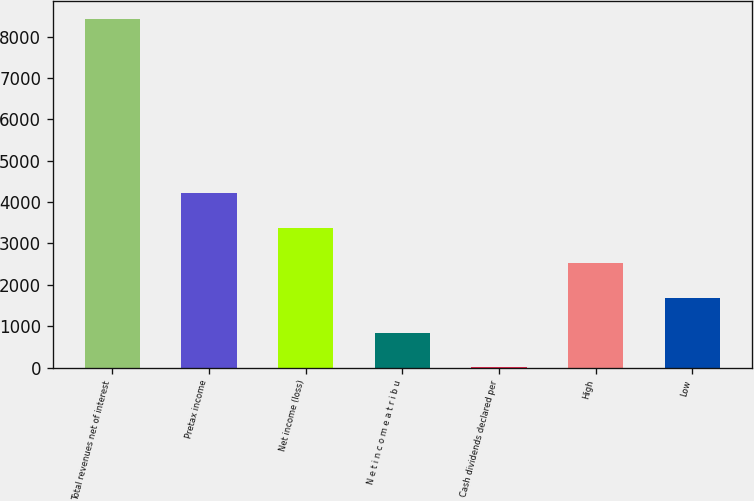Convert chart to OTSL. <chart><loc_0><loc_0><loc_500><loc_500><bar_chart><fcel>Total revenues net of interest<fcel>Pretax income<fcel>Net income (loss)<fcel>N e t i n c o m e a t r i b u<fcel>Cash dividends declared per<fcel>High<fcel>Low<nl><fcel>8436<fcel>4218.18<fcel>3374.62<fcel>843.92<fcel>0.35<fcel>2531.06<fcel>1687.49<nl></chart> 